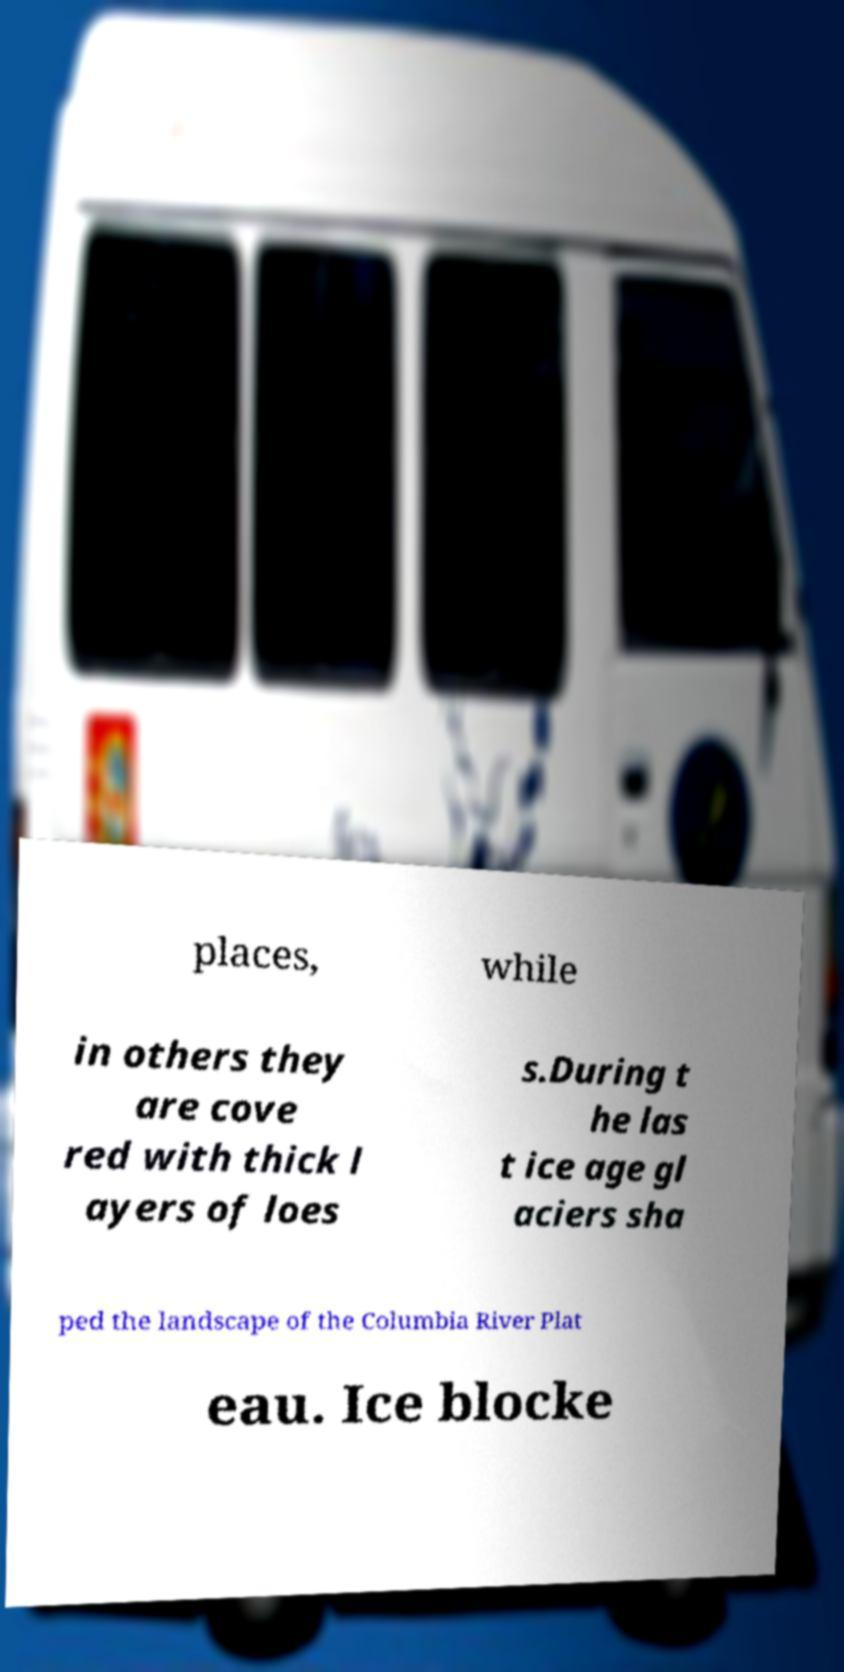For documentation purposes, I need the text within this image transcribed. Could you provide that? places, while in others they are cove red with thick l ayers of loes s.During t he las t ice age gl aciers sha ped the landscape of the Columbia River Plat eau. Ice blocke 